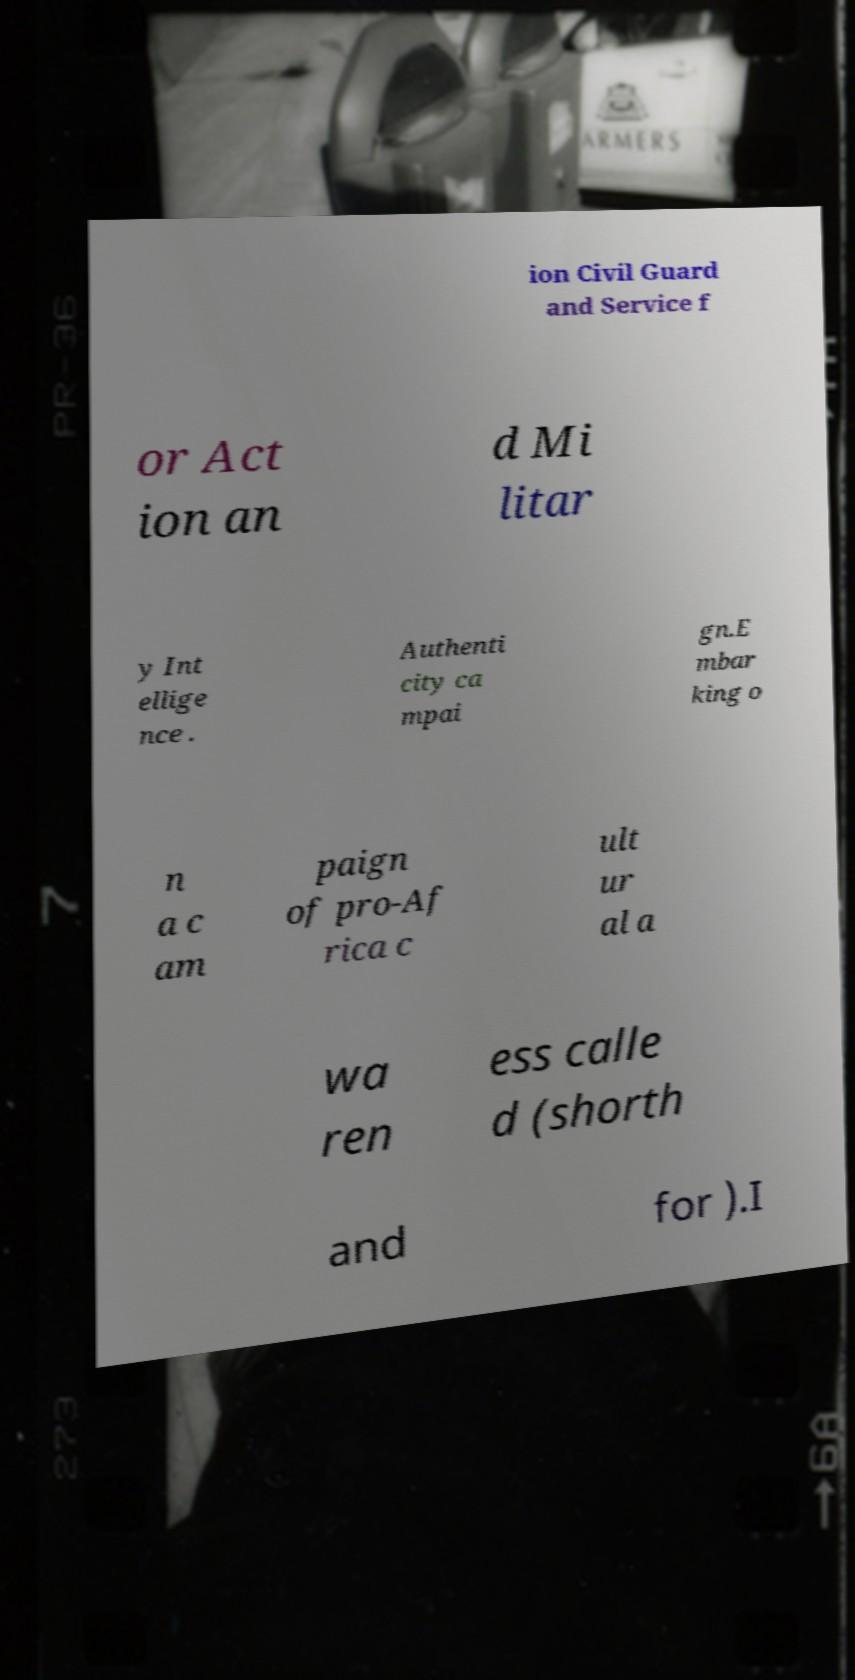What messages or text are displayed in this image? I need them in a readable, typed format. ion Civil Guard and Service f or Act ion an d Mi litar y Int ellige nce . Authenti city ca mpai gn.E mbar king o n a c am paign of pro-Af rica c ult ur al a wa ren ess calle d (shorth and for ).I 